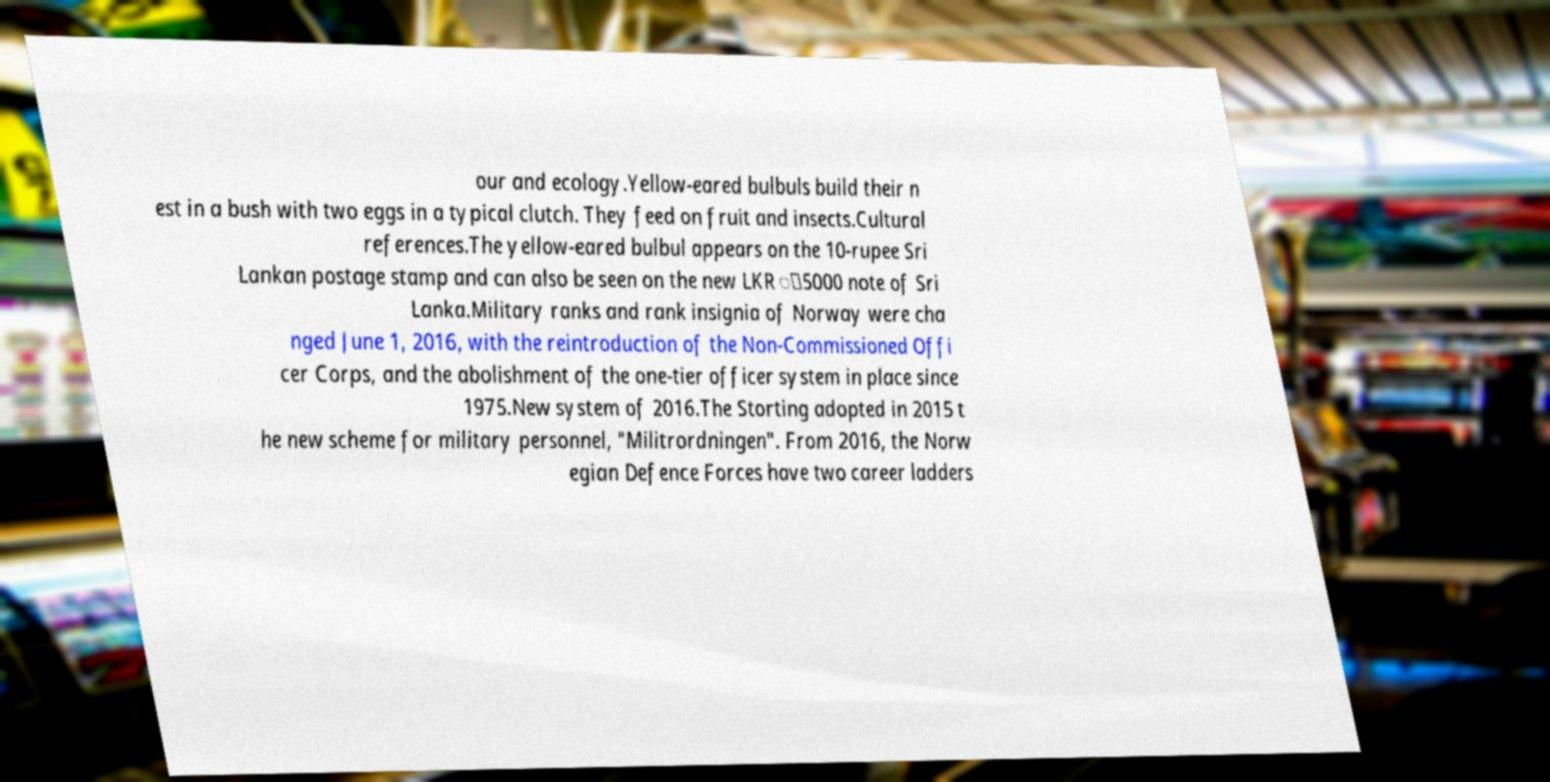Could you assist in decoding the text presented in this image and type it out clearly? our and ecology.Yellow-eared bulbuls build their n est in a bush with two eggs in a typical clutch. They feed on fruit and insects.Cultural references.The yellow-eared bulbul appears on the 10-rupee Sri Lankan postage stamp and can also be seen on the new LKR ු5000 note of Sri Lanka.Military ranks and rank insignia of Norway were cha nged June 1, 2016, with the reintroduction of the Non-Commissioned Offi cer Corps, and the abolishment of the one-tier officer system in place since 1975.New system of 2016.The Storting adopted in 2015 t he new scheme for military personnel, "Militrordningen". From 2016, the Norw egian Defence Forces have two career ladders 